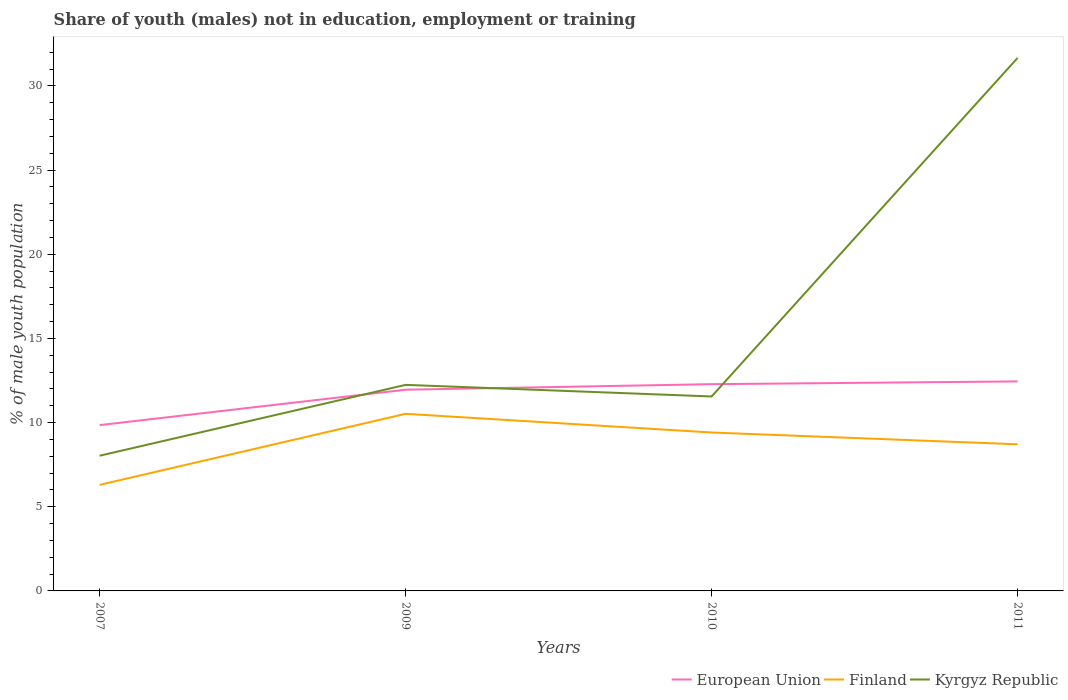Does the line corresponding to Kyrgyz Republic intersect with the line corresponding to Finland?
Give a very brief answer. No. Across all years, what is the maximum percentage of unemployed males population in in Kyrgyz Republic?
Keep it short and to the point. 8.03. What is the total percentage of unemployed males population in in Kyrgyz Republic in the graph?
Your answer should be compact. 0.69. What is the difference between the highest and the second highest percentage of unemployed males population in in European Union?
Offer a very short reply. 2.6. What is the difference between the highest and the lowest percentage of unemployed males population in in Kyrgyz Republic?
Your answer should be very brief. 1. How many years are there in the graph?
Offer a terse response. 4. What is the difference between two consecutive major ticks on the Y-axis?
Provide a succinct answer. 5. Does the graph contain any zero values?
Provide a succinct answer. No. Does the graph contain grids?
Keep it short and to the point. No. Where does the legend appear in the graph?
Ensure brevity in your answer.  Bottom right. How are the legend labels stacked?
Offer a terse response. Horizontal. What is the title of the graph?
Your response must be concise. Share of youth (males) not in education, employment or training. What is the label or title of the Y-axis?
Offer a very short reply. % of male youth population. What is the % of male youth population of European Union in 2007?
Your answer should be very brief. 9.85. What is the % of male youth population in Finland in 2007?
Make the answer very short. 6.3. What is the % of male youth population of Kyrgyz Republic in 2007?
Your answer should be very brief. 8.03. What is the % of male youth population of European Union in 2009?
Offer a very short reply. 11.95. What is the % of male youth population of Finland in 2009?
Provide a succinct answer. 10.52. What is the % of male youth population of Kyrgyz Republic in 2009?
Provide a succinct answer. 12.24. What is the % of male youth population in European Union in 2010?
Offer a terse response. 12.28. What is the % of male youth population in Finland in 2010?
Keep it short and to the point. 9.41. What is the % of male youth population in Kyrgyz Republic in 2010?
Your answer should be compact. 11.55. What is the % of male youth population of European Union in 2011?
Make the answer very short. 12.45. What is the % of male youth population in Finland in 2011?
Provide a short and direct response. 8.71. What is the % of male youth population in Kyrgyz Republic in 2011?
Offer a terse response. 31.66. Across all years, what is the maximum % of male youth population of European Union?
Your answer should be very brief. 12.45. Across all years, what is the maximum % of male youth population in Finland?
Your answer should be compact. 10.52. Across all years, what is the maximum % of male youth population of Kyrgyz Republic?
Offer a very short reply. 31.66. Across all years, what is the minimum % of male youth population in European Union?
Offer a terse response. 9.85. Across all years, what is the minimum % of male youth population in Finland?
Give a very brief answer. 6.3. Across all years, what is the minimum % of male youth population in Kyrgyz Republic?
Offer a very short reply. 8.03. What is the total % of male youth population of European Union in the graph?
Your answer should be compact. 46.53. What is the total % of male youth population of Finland in the graph?
Provide a succinct answer. 34.94. What is the total % of male youth population in Kyrgyz Republic in the graph?
Keep it short and to the point. 63.48. What is the difference between the % of male youth population in European Union in 2007 and that in 2009?
Your answer should be compact. -2.1. What is the difference between the % of male youth population in Finland in 2007 and that in 2009?
Your answer should be very brief. -4.22. What is the difference between the % of male youth population in Kyrgyz Republic in 2007 and that in 2009?
Offer a very short reply. -4.21. What is the difference between the % of male youth population in European Union in 2007 and that in 2010?
Provide a succinct answer. -2.43. What is the difference between the % of male youth population in Finland in 2007 and that in 2010?
Keep it short and to the point. -3.11. What is the difference between the % of male youth population of Kyrgyz Republic in 2007 and that in 2010?
Your response must be concise. -3.52. What is the difference between the % of male youth population in European Union in 2007 and that in 2011?
Your response must be concise. -2.6. What is the difference between the % of male youth population of Finland in 2007 and that in 2011?
Your response must be concise. -2.41. What is the difference between the % of male youth population of Kyrgyz Republic in 2007 and that in 2011?
Provide a succinct answer. -23.63. What is the difference between the % of male youth population of European Union in 2009 and that in 2010?
Keep it short and to the point. -0.33. What is the difference between the % of male youth population in Finland in 2009 and that in 2010?
Offer a terse response. 1.11. What is the difference between the % of male youth population of Kyrgyz Republic in 2009 and that in 2010?
Provide a succinct answer. 0.69. What is the difference between the % of male youth population of European Union in 2009 and that in 2011?
Offer a very short reply. -0.49. What is the difference between the % of male youth population in Finland in 2009 and that in 2011?
Offer a terse response. 1.81. What is the difference between the % of male youth population in Kyrgyz Republic in 2009 and that in 2011?
Offer a very short reply. -19.42. What is the difference between the % of male youth population of European Union in 2010 and that in 2011?
Your response must be concise. -0.16. What is the difference between the % of male youth population in Kyrgyz Republic in 2010 and that in 2011?
Provide a short and direct response. -20.11. What is the difference between the % of male youth population in European Union in 2007 and the % of male youth population in Finland in 2009?
Your answer should be compact. -0.67. What is the difference between the % of male youth population in European Union in 2007 and the % of male youth population in Kyrgyz Republic in 2009?
Offer a very short reply. -2.39. What is the difference between the % of male youth population in Finland in 2007 and the % of male youth population in Kyrgyz Republic in 2009?
Ensure brevity in your answer.  -5.94. What is the difference between the % of male youth population of European Union in 2007 and the % of male youth population of Finland in 2010?
Keep it short and to the point. 0.44. What is the difference between the % of male youth population in European Union in 2007 and the % of male youth population in Kyrgyz Republic in 2010?
Your answer should be very brief. -1.7. What is the difference between the % of male youth population of Finland in 2007 and the % of male youth population of Kyrgyz Republic in 2010?
Your response must be concise. -5.25. What is the difference between the % of male youth population in European Union in 2007 and the % of male youth population in Finland in 2011?
Offer a terse response. 1.14. What is the difference between the % of male youth population of European Union in 2007 and the % of male youth population of Kyrgyz Republic in 2011?
Ensure brevity in your answer.  -21.81. What is the difference between the % of male youth population in Finland in 2007 and the % of male youth population in Kyrgyz Republic in 2011?
Ensure brevity in your answer.  -25.36. What is the difference between the % of male youth population of European Union in 2009 and the % of male youth population of Finland in 2010?
Ensure brevity in your answer.  2.54. What is the difference between the % of male youth population of European Union in 2009 and the % of male youth population of Kyrgyz Republic in 2010?
Ensure brevity in your answer.  0.4. What is the difference between the % of male youth population in Finland in 2009 and the % of male youth population in Kyrgyz Republic in 2010?
Give a very brief answer. -1.03. What is the difference between the % of male youth population of European Union in 2009 and the % of male youth population of Finland in 2011?
Your answer should be compact. 3.24. What is the difference between the % of male youth population of European Union in 2009 and the % of male youth population of Kyrgyz Republic in 2011?
Your answer should be compact. -19.71. What is the difference between the % of male youth population in Finland in 2009 and the % of male youth population in Kyrgyz Republic in 2011?
Your response must be concise. -21.14. What is the difference between the % of male youth population of European Union in 2010 and the % of male youth population of Finland in 2011?
Give a very brief answer. 3.57. What is the difference between the % of male youth population of European Union in 2010 and the % of male youth population of Kyrgyz Republic in 2011?
Offer a very short reply. -19.38. What is the difference between the % of male youth population in Finland in 2010 and the % of male youth population in Kyrgyz Republic in 2011?
Make the answer very short. -22.25. What is the average % of male youth population in European Union per year?
Offer a very short reply. 11.63. What is the average % of male youth population in Finland per year?
Your answer should be compact. 8.73. What is the average % of male youth population in Kyrgyz Republic per year?
Ensure brevity in your answer.  15.87. In the year 2007, what is the difference between the % of male youth population of European Union and % of male youth population of Finland?
Provide a succinct answer. 3.55. In the year 2007, what is the difference between the % of male youth population in European Union and % of male youth population in Kyrgyz Republic?
Offer a terse response. 1.82. In the year 2007, what is the difference between the % of male youth population of Finland and % of male youth population of Kyrgyz Republic?
Provide a succinct answer. -1.73. In the year 2009, what is the difference between the % of male youth population in European Union and % of male youth population in Finland?
Keep it short and to the point. 1.43. In the year 2009, what is the difference between the % of male youth population in European Union and % of male youth population in Kyrgyz Republic?
Provide a succinct answer. -0.29. In the year 2009, what is the difference between the % of male youth population in Finland and % of male youth population in Kyrgyz Republic?
Your answer should be very brief. -1.72. In the year 2010, what is the difference between the % of male youth population in European Union and % of male youth population in Finland?
Your answer should be very brief. 2.87. In the year 2010, what is the difference between the % of male youth population in European Union and % of male youth population in Kyrgyz Republic?
Provide a short and direct response. 0.73. In the year 2010, what is the difference between the % of male youth population in Finland and % of male youth population in Kyrgyz Republic?
Keep it short and to the point. -2.14. In the year 2011, what is the difference between the % of male youth population in European Union and % of male youth population in Finland?
Keep it short and to the point. 3.73. In the year 2011, what is the difference between the % of male youth population in European Union and % of male youth population in Kyrgyz Republic?
Your answer should be very brief. -19.21. In the year 2011, what is the difference between the % of male youth population of Finland and % of male youth population of Kyrgyz Republic?
Provide a short and direct response. -22.95. What is the ratio of the % of male youth population in European Union in 2007 to that in 2009?
Make the answer very short. 0.82. What is the ratio of the % of male youth population in Finland in 2007 to that in 2009?
Offer a terse response. 0.6. What is the ratio of the % of male youth population of Kyrgyz Republic in 2007 to that in 2009?
Your answer should be compact. 0.66. What is the ratio of the % of male youth population in European Union in 2007 to that in 2010?
Provide a succinct answer. 0.8. What is the ratio of the % of male youth population in Finland in 2007 to that in 2010?
Your answer should be very brief. 0.67. What is the ratio of the % of male youth population of Kyrgyz Republic in 2007 to that in 2010?
Provide a short and direct response. 0.7. What is the ratio of the % of male youth population in European Union in 2007 to that in 2011?
Ensure brevity in your answer.  0.79. What is the ratio of the % of male youth population of Finland in 2007 to that in 2011?
Provide a short and direct response. 0.72. What is the ratio of the % of male youth population of Kyrgyz Republic in 2007 to that in 2011?
Make the answer very short. 0.25. What is the ratio of the % of male youth population of European Union in 2009 to that in 2010?
Offer a terse response. 0.97. What is the ratio of the % of male youth population in Finland in 2009 to that in 2010?
Make the answer very short. 1.12. What is the ratio of the % of male youth population in Kyrgyz Republic in 2009 to that in 2010?
Ensure brevity in your answer.  1.06. What is the ratio of the % of male youth population of European Union in 2009 to that in 2011?
Keep it short and to the point. 0.96. What is the ratio of the % of male youth population in Finland in 2009 to that in 2011?
Your response must be concise. 1.21. What is the ratio of the % of male youth population of Kyrgyz Republic in 2009 to that in 2011?
Provide a short and direct response. 0.39. What is the ratio of the % of male youth population of Finland in 2010 to that in 2011?
Offer a terse response. 1.08. What is the ratio of the % of male youth population in Kyrgyz Republic in 2010 to that in 2011?
Keep it short and to the point. 0.36. What is the difference between the highest and the second highest % of male youth population in European Union?
Make the answer very short. 0.16. What is the difference between the highest and the second highest % of male youth population in Finland?
Offer a terse response. 1.11. What is the difference between the highest and the second highest % of male youth population of Kyrgyz Republic?
Offer a very short reply. 19.42. What is the difference between the highest and the lowest % of male youth population of European Union?
Ensure brevity in your answer.  2.6. What is the difference between the highest and the lowest % of male youth population in Finland?
Make the answer very short. 4.22. What is the difference between the highest and the lowest % of male youth population of Kyrgyz Republic?
Offer a terse response. 23.63. 